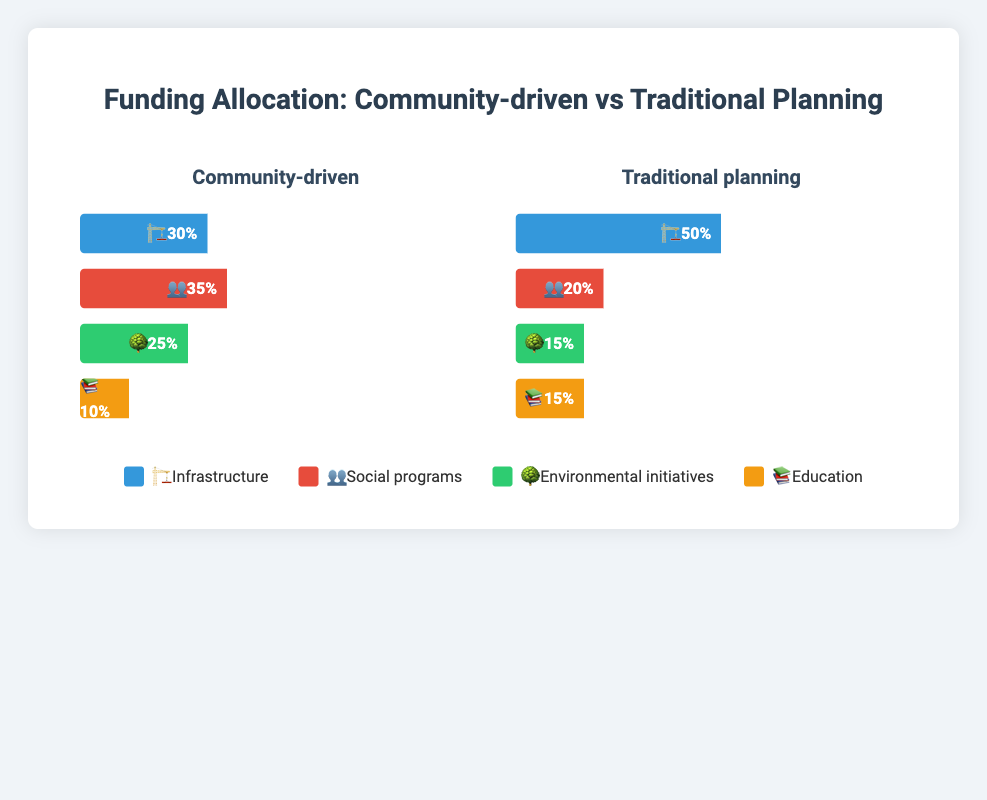What percentage of funding is allocated to social programs in community-driven projects? The bar for social programs in the community-driven section is labeled 👥 with a percentage value shown.
Answer: 35% What is the total percentage of funding allocated to infrastructure and environmental initiatives in traditional planning approaches? Add the values of infrastructure (50%) and environmental initiatives (15%) in the traditional planning section.
Answer: 65% Which project type allocates a higher percentage of funding to education, and by how much? Compare the education funding percentages between community-driven (10%) and traditional planning (15%) sections. Subtract the smaller value from the larger one.
Answer: Traditional planning, 5% How does the allocation for environmental initiatives differ between community-driven projects and traditional planning approaches? Subtract the percentage of environmental initiatives in traditional planning (15%) from community-driven (25%).
Answer: Community-driven allocates 10% more Which funding category receives the least allocation in community-driven projects? Identify the smallest percentage value in the community-driven section, which corresponds to education (10%).
Answer: Education What is the combined funding percentage of social programs and education in traditional planning approaches? Add the values for social programs (20%) and education (15%) in the traditional planning section.
Answer: 35% Between community-driven and traditional planning approaches, which has a more balanced funding allocation across all categories? Compare the largest and smallest values in both sections. Community-driven ranges from 10% to 35%, while traditional planning ranges from 15% to 50%.
Answer: Community-driven What percentage of funding is allocated to infrastructure in community-driven projects? The bar for infrastructure in the community-driven section is labeled 🏗️ with a percentage value.
Answer: 30% How much more funding do community-driven projects allocate to social programs compared to traditional planning approaches? Subtract the percentage of social programs in traditional planning (20%) from community-driven (35%).
Answer: 15% Which funding category is given equal percentage in both project types? Identify categories where the percentages are the same in both sections, which is education (15%).
Answer: Education 